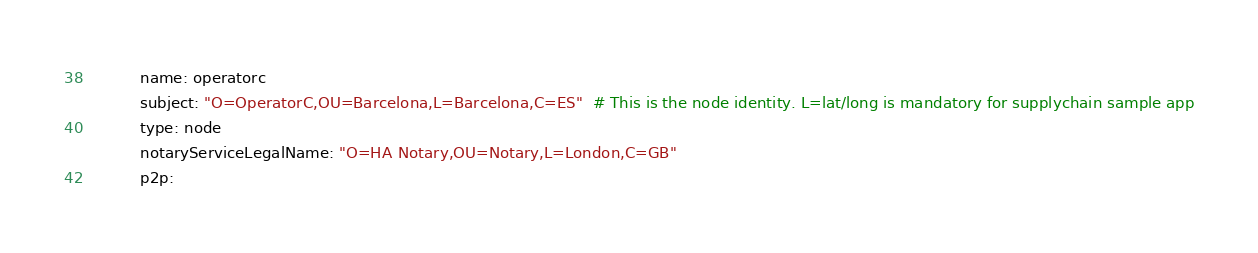Convert code to text. <code><loc_0><loc_0><loc_500><loc_500><_YAML_>          name: operatorc
          subject: "O=OperatorC,OU=Barcelona,L=Barcelona,C=ES"  # This is the node identity. L=lat/long is mandatory for supplychain sample app
          type: node
          notaryServiceLegalName: "O=HA Notary,OU=Notary,L=London,C=GB"
          p2p:</code> 